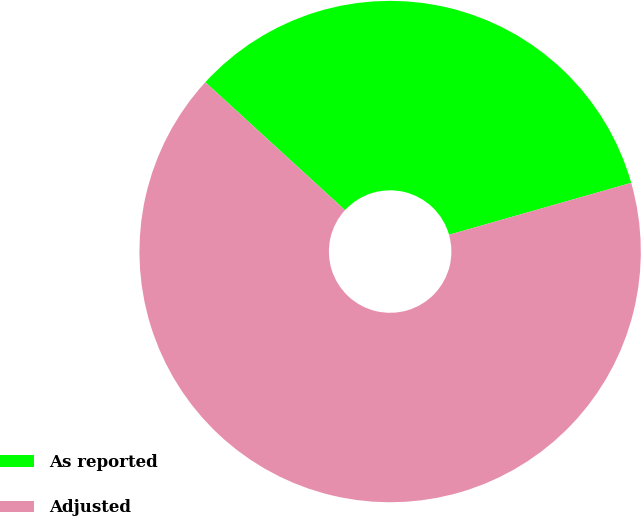Convert chart to OTSL. <chart><loc_0><loc_0><loc_500><loc_500><pie_chart><fcel>As reported<fcel>Adjusted<nl><fcel>33.78%<fcel>66.22%<nl></chart> 